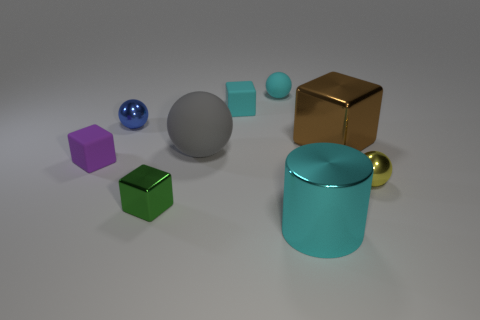Subtract all yellow metal spheres. How many spheres are left? 3 Subtract all cyan blocks. How many blocks are left? 3 Subtract all cylinders. How many objects are left? 8 Subtract all purple balls. Subtract all brown blocks. How many balls are left? 4 Subtract all tiny yellow shiny objects. Subtract all cyan rubber spheres. How many objects are left? 7 Add 4 shiny balls. How many shiny balls are left? 6 Add 9 yellow rubber balls. How many yellow rubber balls exist? 9 Subtract 0 blue cylinders. How many objects are left? 9 